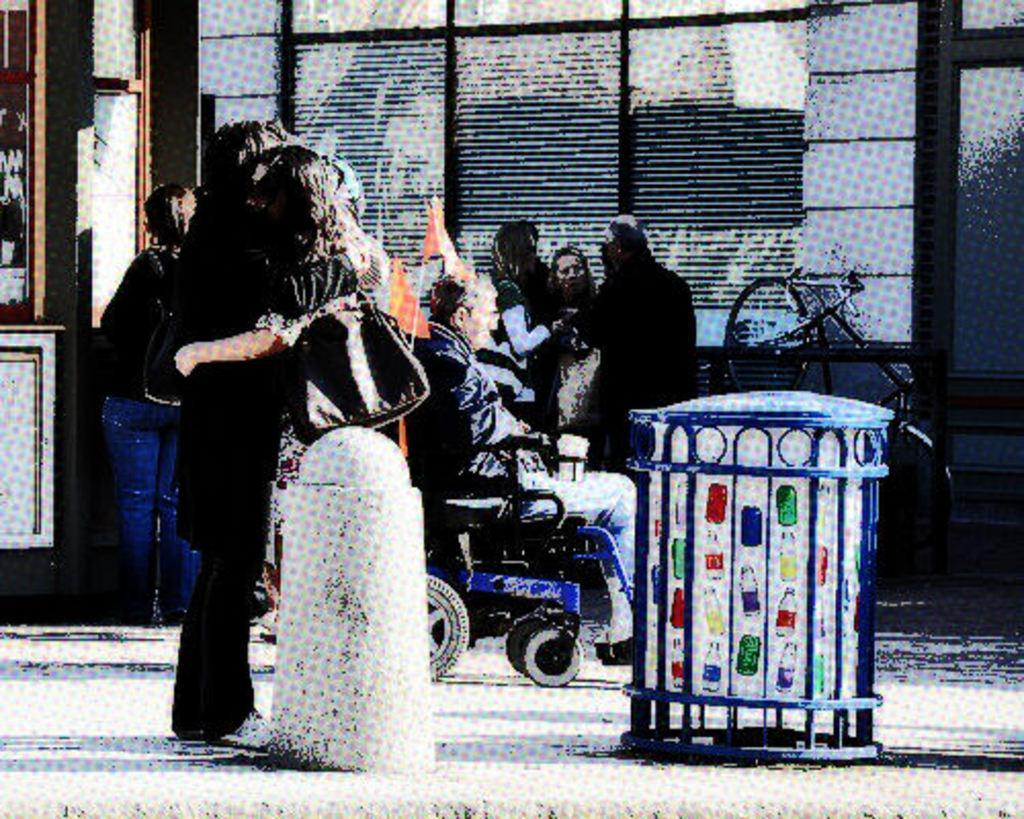How would you summarize this image in a sentence or two? In the middle of the image few people are standing and a person is sitting on a wheelchair. Behind them there is a wall. 